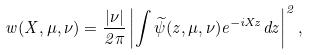<formula> <loc_0><loc_0><loc_500><loc_500>w ( X , \mu , \nu ) = \frac { | \nu | } { 2 \pi } \left | \int \widetilde { \psi } ( z , \mu , \nu ) e ^ { - i X z } d z \right | ^ { 2 } ,</formula> 